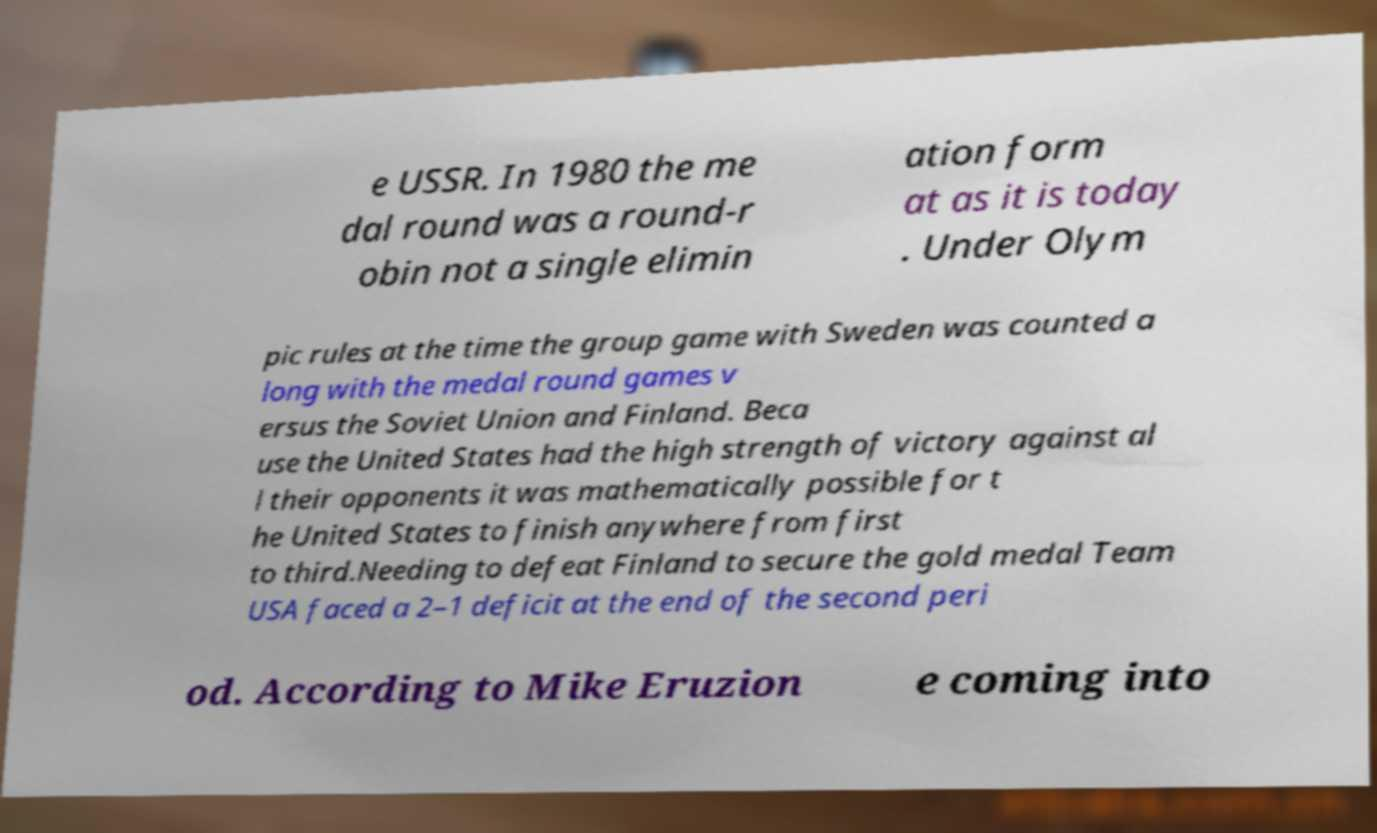Could you extract and type out the text from this image? e USSR. In 1980 the me dal round was a round-r obin not a single elimin ation form at as it is today . Under Olym pic rules at the time the group game with Sweden was counted a long with the medal round games v ersus the Soviet Union and Finland. Beca use the United States had the high strength of victory against al l their opponents it was mathematically possible for t he United States to finish anywhere from first to third.Needing to defeat Finland to secure the gold medal Team USA faced a 2–1 deficit at the end of the second peri od. According to Mike Eruzion e coming into 